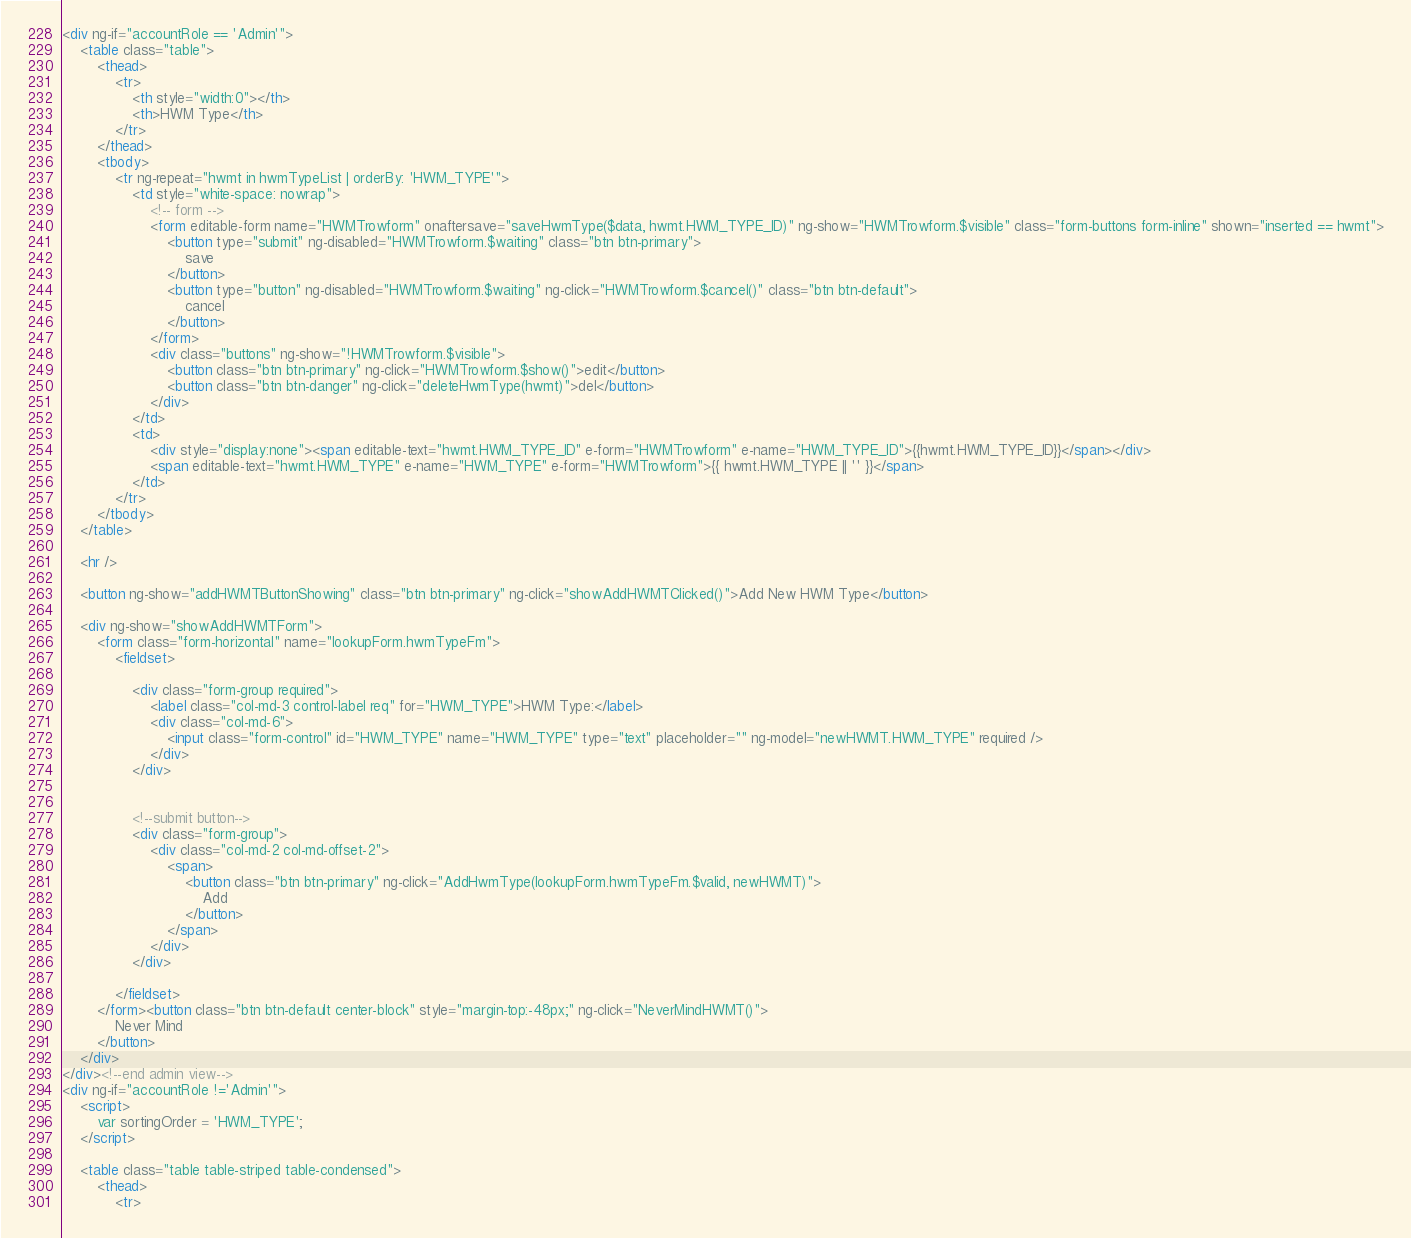<code> <loc_0><loc_0><loc_500><loc_500><_HTML_><div ng-if="accountRole == 'Admin'">
    <table class="table">
        <thead>
            <tr>
                <th style="width:0"></th>
                <th>HWM Type</th>
            </tr>
        </thead>
        <tbody>
            <tr ng-repeat="hwmt in hwmTypeList | orderBy: 'HWM_TYPE'">
                <td style="white-space: nowrap">
                    <!-- form -->
                    <form editable-form name="HWMTrowform" onaftersave="saveHwmType($data, hwmt.HWM_TYPE_ID)" ng-show="HWMTrowform.$visible" class="form-buttons form-inline" shown="inserted == hwmt">
                        <button type="submit" ng-disabled="HWMTrowform.$waiting" class="btn btn-primary">
                            save
                        </button>
                        <button type="button" ng-disabled="HWMTrowform.$waiting" ng-click="HWMTrowform.$cancel()" class="btn btn-default">
                            cancel
                        </button>
                    </form>
                    <div class="buttons" ng-show="!HWMTrowform.$visible">
                        <button class="btn btn-primary" ng-click="HWMTrowform.$show()">edit</button>
                        <button class="btn btn-danger" ng-click="deleteHwmType(hwmt)">del</button>
                    </div>
                </td>
                <td>
                    <div style="display:none"><span editable-text="hwmt.HWM_TYPE_ID" e-form="HWMTrowform" e-name="HWM_TYPE_ID">{{hwmt.HWM_TYPE_ID}}</span></div>
                    <span editable-text="hwmt.HWM_TYPE" e-name="HWM_TYPE" e-form="HWMTrowform">{{ hwmt.HWM_TYPE || '' }}</span>
                </td>
            </tr>
        </tbody>
    </table>

    <hr />

    <button ng-show="addHWMTButtonShowing" class="btn btn-primary" ng-click="showAddHWMTClicked()">Add New HWM Type</button>

    <div ng-show="showAddHWMTForm">
        <form class="form-horizontal" name="lookupForm.hwmTypeFm">
            <fieldset>

                <div class="form-group required">
                    <label class="col-md-3 control-label req" for="HWM_TYPE">HWM Type:</label>
                    <div class="col-md-6">
                        <input class="form-control" id="HWM_TYPE" name="HWM_TYPE" type="text" placeholder="" ng-model="newHWMT.HWM_TYPE" required />
                    </div>
                </div>


                <!--submit button-->
                <div class="form-group">
                    <div class="col-md-2 col-md-offset-2">
                        <span>
                            <button class="btn btn-primary" ng-click="AddHwmType(lookupForm.hwmTypeFm.$valid, newHWMT)">
                                Add
                            </button>
                        </span>
                    </div>
                </div>

            </fieldset>
        </form><button class="btn btn-default center-block" style="margin-top:-48px;" ng-click="NeverMindHWMT()">
            Never Mind
        </button>
    </div>
</div><!--end admin view-->
<div ng-if="accountRole !='Admin'">
    <script>
        var sortingOrder = 'HWM_TYPE';
    </script>

    <table class="table table-striped table-condensed">
        <thead>
            <tr></code> 